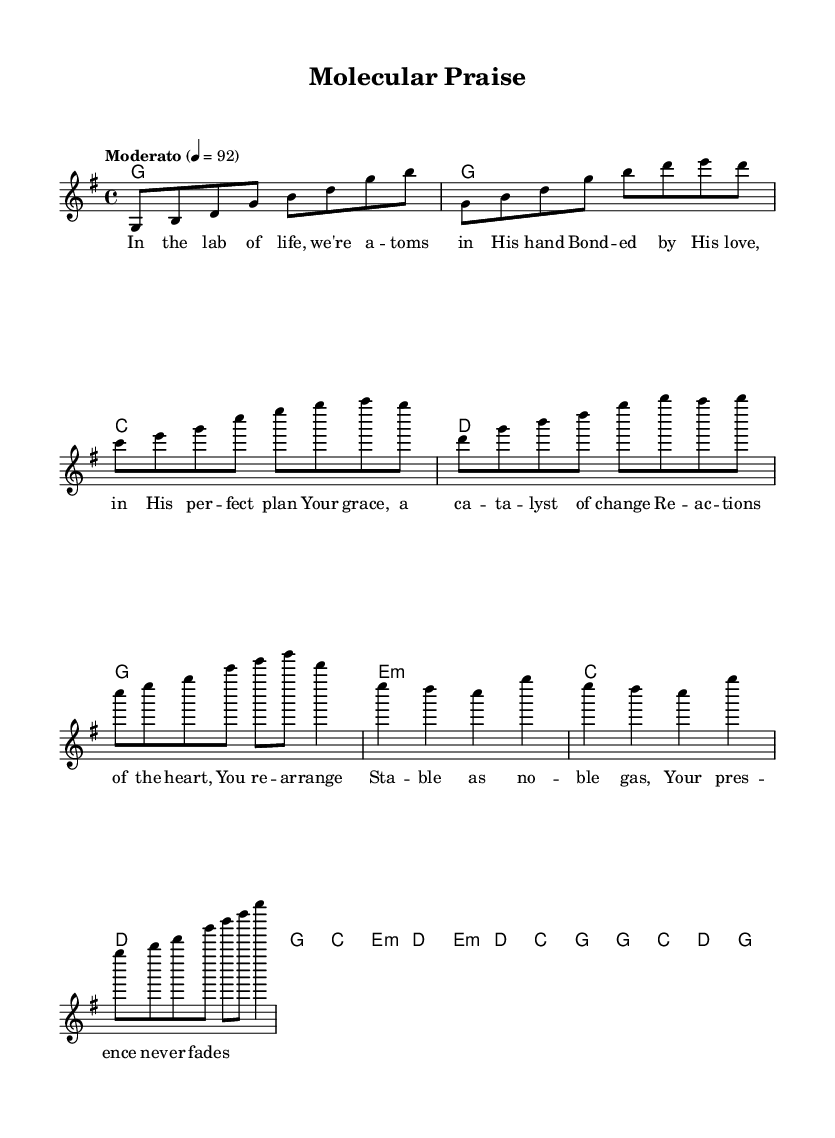What is the key signature of this music? The key signature is G major, which has one sharp (F#). This can be identified in the global section of the code where it specifies "\key g \major".
Answer: G major What is the time signature of this piece? The time signature is 4/4, as indicated in the global section of the code where it states "\time 4/4". This tells us that there are four beats in each measure.
Answer: 4/4 What is the tempo marking for the music? The tempo marking is Moderato, set to 92 beats per minute, as detailed in the global section of the code with "\tempo "Moderato" 4 = 92". This indicates a moderate pace for the performance.
Answer: Moderato, 92 How many measures does the chorus contain? The chorus section consists of 4 measures, identifiable by the concluding part of the harmonies and melody segments, which each have 4 distinct musical phrases corresponding to 4 measures.
Answer: 4 What metaphor is used to describe God's grace in the lyrics of the chorus? The metaphor is a catalyst, suggesting that God's grace facilitates change within one's heart, as stated in the lyrical phrase "Your grace, a catalyst of change". This compares God's influence to a chemical catalyst that initiates reactions.
Answer: Catalyst Which instrument primarily carries the melody in this composition? The melody is primarily carried by the lead voice, as indicated by the voice assignment "\new Voice = "lead" {". The code structure separates the melody from the harmonies, confirming that the lead voice is the melody's main carrier.
Answer: Lead voice What does the bridge describe about God's presence? The bridge describes God's presence as "stable as noble gas", suggesting consistency and permanence, drawing a parallel to the scientific properties of noble gases that are inert and stable. This creative use of scientific metaphor enhances the expression of faith.
Answer: Stable as noble gas 